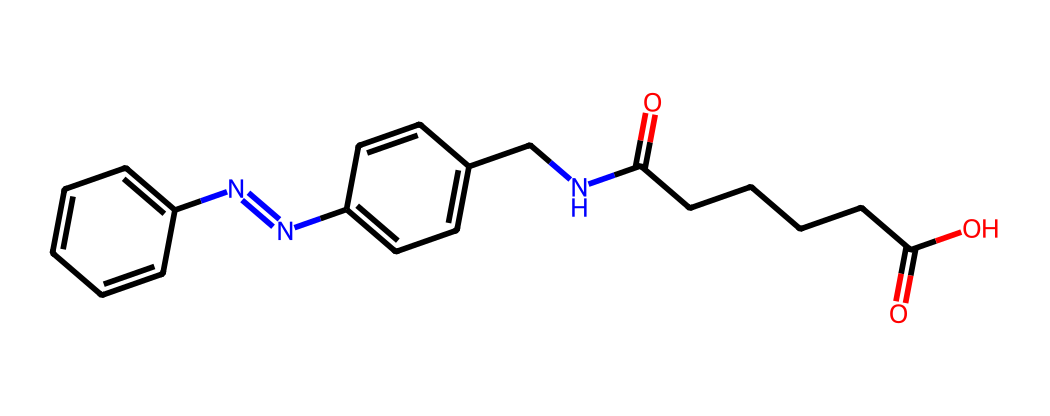What is the total number of carbon atoms in this compound? By analyzing the SMILES representation, we can count the carbon atoms. The structure contains six carbon atoms from the first aromatic ring, six from the second aromatic ring, and additional carbon atoms from the NC(=O)CCCCC(=O)O part, leading to a total of 17 carbon atoms.
Answer: 17 How many nitrogen atoms are present in the chemical structure? In the given SMILES, we can identify two nitrogen atoms used in the azobenzene structure (N=N) and two more in the remaining structure. Thus, the total count becomes four nitrogen atoms in this compound.
Answer: 4 Does this compound contain any functional groups? This compound has multiple functional groups such as amide (C(=O)N), carboxylic acid (C(=O)O), which are part of the amide and acid structures visible in the SMILES.
Answer: yes What is the main characteristic that distinguishes E/Z isomers in this compound? The defining feature of E/Z isomerism is the positioning of substituents around the double bond. In this compound, the presence of the nitrogen double bond (N=N) acts as the pivot, allowing for E or Z configurations based on the placement of substituents relative to this bond.
Answer: substitution Which part of the molecular structure contains the double bond that defines the E/Z configuration? The double bond is located between the two nitrogen atoms in the azobenzene part of the structure, denoted by N=N. This bond is crucial for establishing the E/Z configuration.
Answer: N=N What type of bond is primarily responsible for the geometric isomerism seen in this drug delivery system? The bond responsible for geometric isomerism in this compound is the double bond, which allows for the existence of different geometric configurations (E or Z). This applies specifically to the nitrogen double bond in azobenzene.
Answer: double bond 